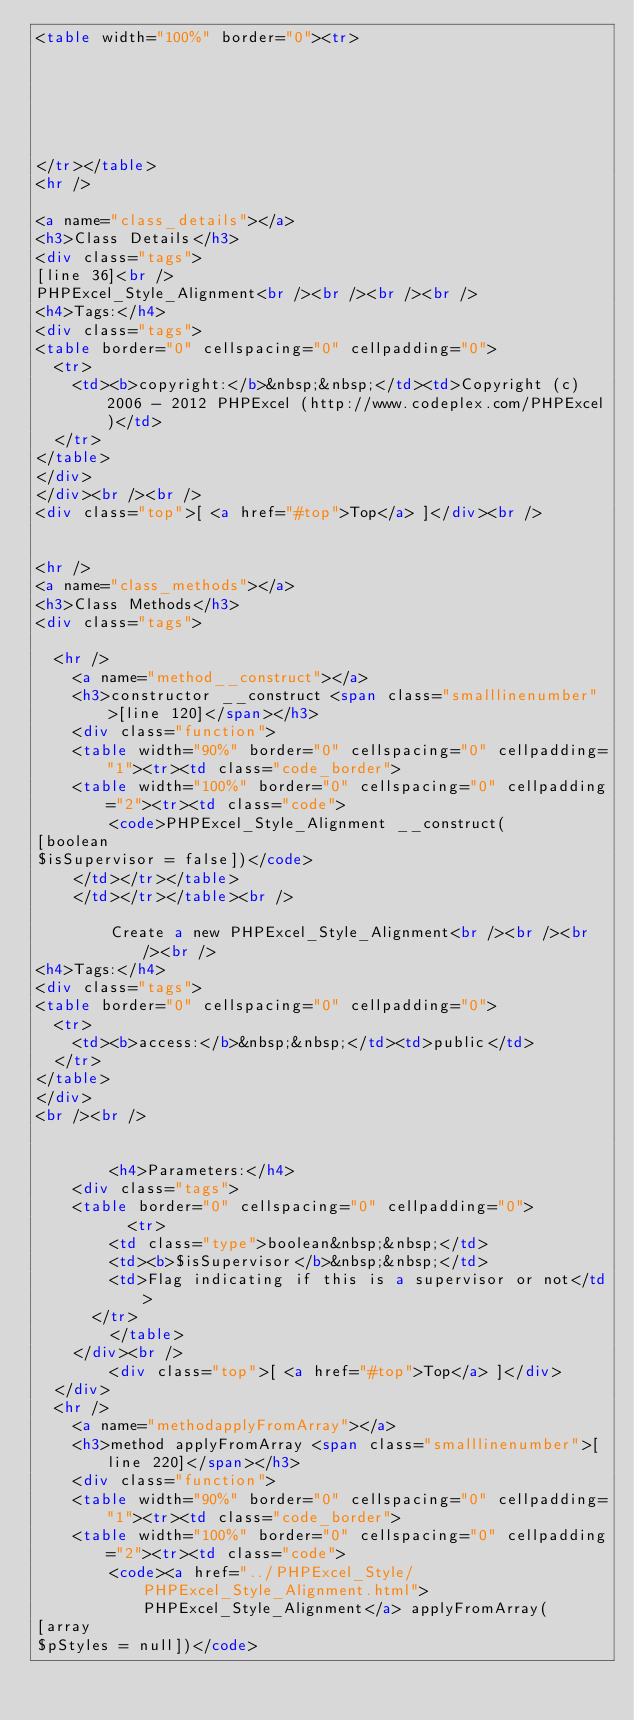<code> <loc_0><loc_0><loc_500><loc_500><_HTML_><table width="100%" border="0"><tr>






</tr></table>
<hr />

<a name="class_details"></a>
<h3>Class Details</h3>
<div class="tags">
[line 36]<br />
PHPExcel_Style_Alignment<br /><br /><br /><br />
<h4>Tags:</h4>
<div class="tags">
<table border="0" cellspacing="0" cellpadding="0">
  <tr>
    <td><b>copyright:</b>&nbsp;&nbsp;</td><td>Copyright (c) 2006 - 2012 PHPExcel (http://www.codeplex.com/PHPExcel)</td>
  </tr>
</table>
</div>
</div><br /><br />
<div class="top">[ <a href="#top">Top</a> ]</div><br />


<hr />
<a name="class_methods"></a>
<h3>Class Methods</h3>
<div class="tags">

  <hr />
	<a name="method__construct"></a>
	<h3>constructor __construct <span class="smalllinenumber">[line 120]</span></h3>
	<div class="function">
    <table width="90%" border="0" cellspacing="0" cellpadding="1"><tr><td class="code_border">
    <table width="100%" border="0" cellspacing="0" cellpadding="2"><tr><td class="code">
		<code>PHPExcel_Style_Alignment __construct(
[boolean
$isSupervisor = false])</code>
    </td></tr></table>
    </td></tr></table><br />
	
		Create a new PHPExcel_Style_Alignment<br /><br /><br /><br />
<h4>Tags:</h4>
<div class="tags">
<table border="0" cellspacing="0" cellpadding="0">
  <tr>
    <td><b>access:</b>&nbsp;&nbsp;</td><td>public</td>
  </tr>
</table>
</div>
<br /><br />

	
        <h4>Parameters:</h4>
    <div class="tags">
    <table border="0" cellspacing="0" cellpadding="0">
          <tr>
        <td class="type">boolean&nbsp;&nbsp;</td>
        <td><b>$isSupervisor</b>&nbsp;&nbsp;</td>
        <td>Flag indicating if this is a supervisor or not</td>
      </tr>
        </table>
    </div><br />
        <div class="top">[ <a href="#top">Top</a> ]</div>
  </div>
  <hr />
	<a name="methodapplyFromArray"></a>
	<h3>method applyFromArray <span class="smalllinenumber">[line 220]</span></h3>
	<div class="function">
    <table width="90%" border="0" cellspacing="0" cellpadding="1"><tr><td class="code_border">
    <table width="100%" border="0" cellspacing="0" cellpadding="2"><tr><td class="code">
		<code><a href="../PHPExcel_Style/PHPExcel_Style_Alignment.html">PHPExcel_Style_Alignment</a> applyFromArray(
[array
$pStyles = null])</code></code> 